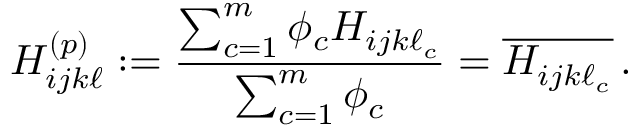Convert formula to latex. <formula><loc_0><loc_0><loc_500><loc_500>H _ { i j k \ell } ^ { ( p ) } \colon = \frac { \sum _ { c = 1 } ^ { m } \phi _ { c } H _ { i j k \ell _ { c } } } { \sum _ { c = 1 } ^ { m } \phi _ { c } } = \overline { { H _ { i j k \ell _ { c } } } } \, .</formula> 